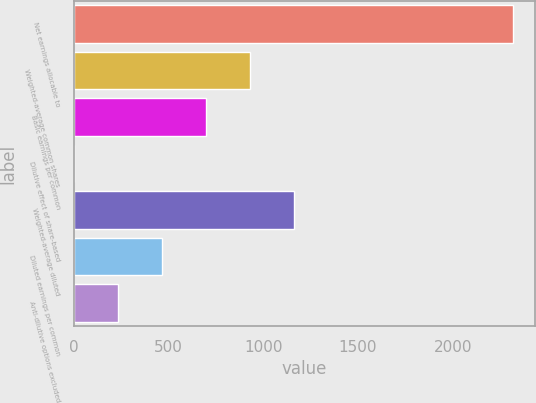<chart> <loc_0><loc_0><loc_500><loc_500><bar_chart><fcel>Net earnings allocable to<fcel>Weighted-average common shares<fcel>Basic earnings per common<fcel>Dilutive effect of share-based<fcel>Weighted-average diluted<fcel>Diluted earnings per common<fcel>Anti-dilutive options excluded<nl><fcel>2320<fcel>929.8<fcel>698.1<fcel>3<fcel>1161.5<fcel>466.4<fcel>234.7<nl></chart> 